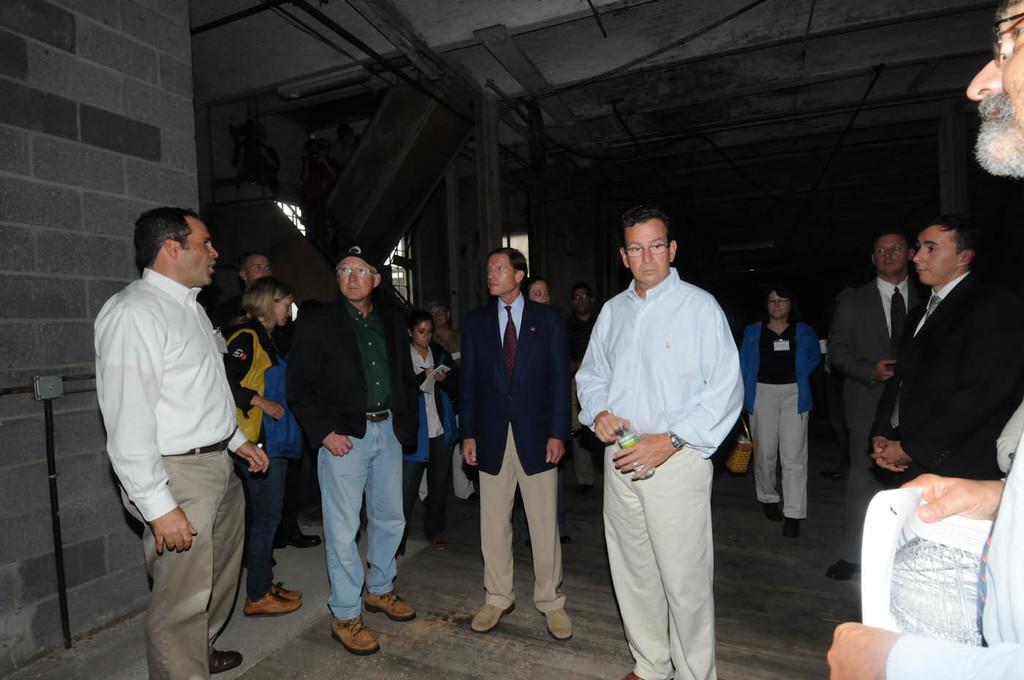Could you give a brief overview of what you see in this image? Here in this picture we can see number of people standing on the floor over there, some people are wearing jackets on them and above them we can see a roof and on the left side we can see a stair case present over there. 